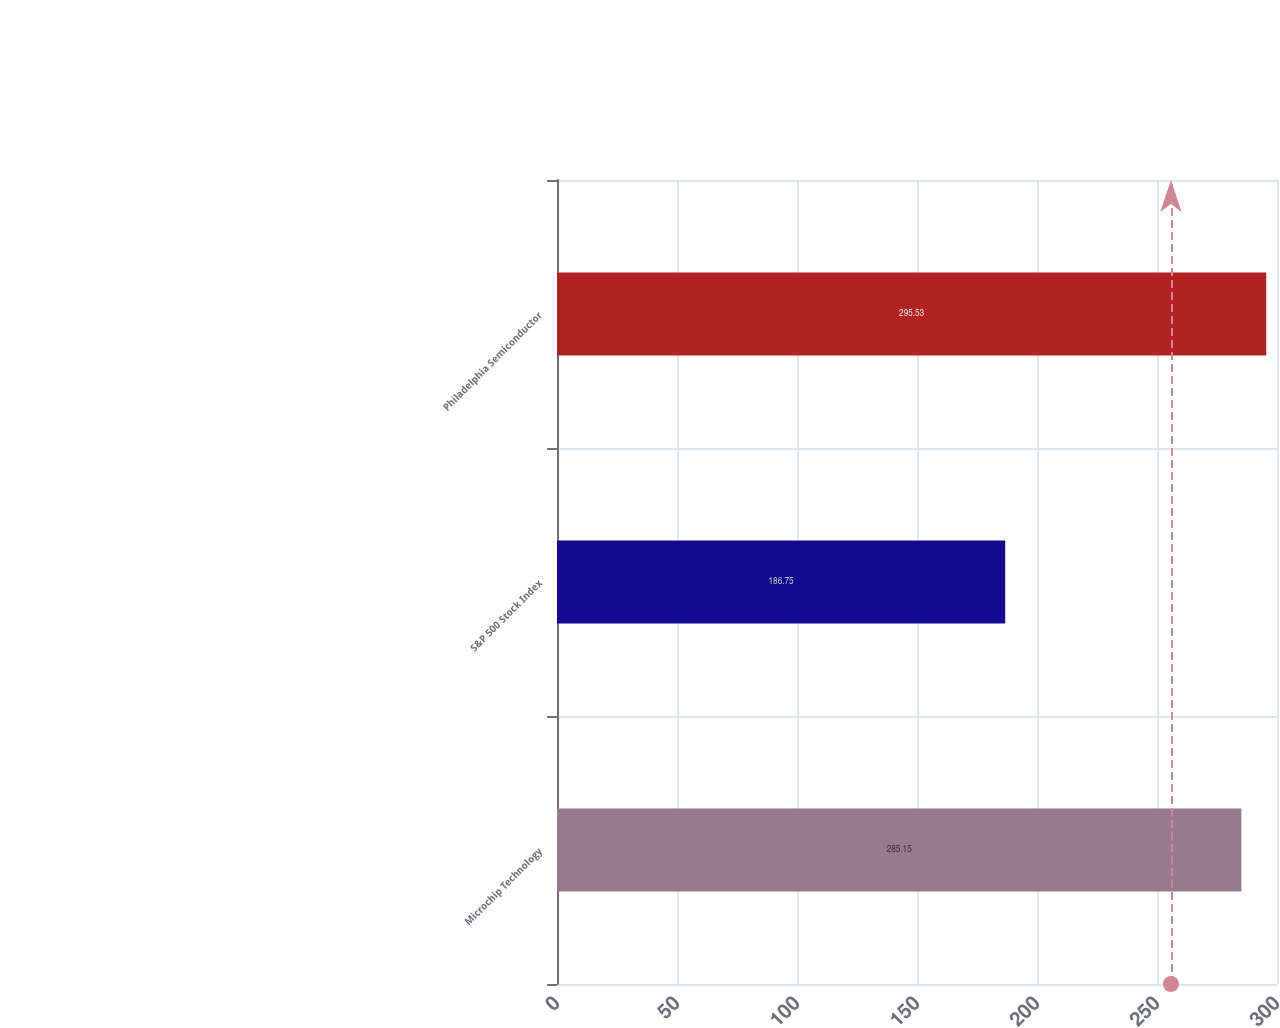Convert chart to OTSL. <chart><loc_0><loc_0><loc_500><loc_500><bar_chart><fcel>Microchip Technology<fcel>S&P 500 Stock Index<fcel>Philadelphia Semiconductor<nl><fcel>285.15<fcel>186.75<fcel>295.53<nl></chart> 